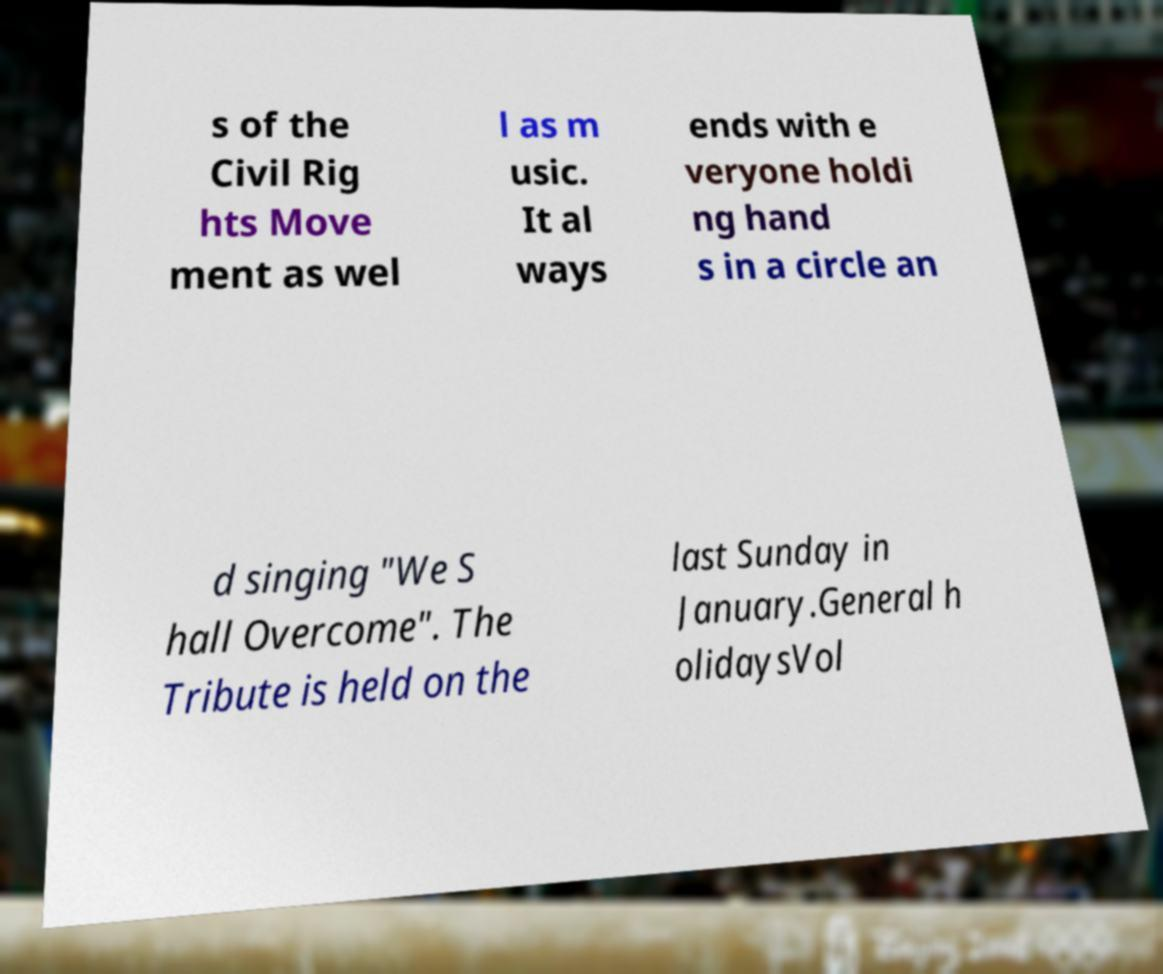Please identify and transcribe the text found in this image. s of the Civil Rig hts Move ment as wel l as m usic. It al ways ends with e veryone holdi ng hand s in a circle an d singing "We S hall Overcome". The Tribute is held on the last Sunday in January.General h olidaysVol 